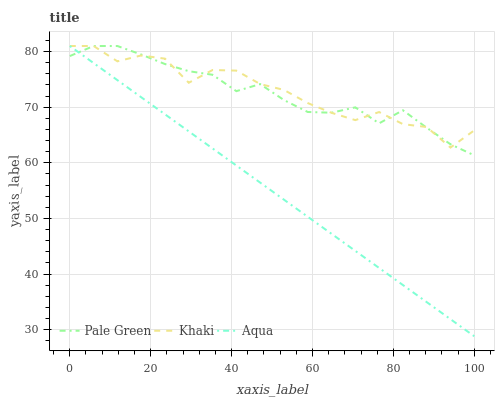Does Aqua have the minimum area under the curve?
Answer yes or no. Yes. Does Khaki have the maximum area under the curve?
Answer yes or no. Yes. Does Khaki have the minimum area under the curve?
Answer yes or no. No. Does Aqua have the maximum area under the curve?
Answer yes or no. No. Is Aqua the smoothest?
Answer yes or no. Yes. Is Khaki the roughest?
Answer yes or no. Yes. Is Khaki the smoothest?
Answer yes or no. No. Is Aqua the roughest?
Answer yes or no. No. Does Aqua have the lowest value?
Answer yes or no. Yes. Does Khaki have the lowest value?
Answer yes or no. No. Does Khaki have the highest value?
Answer yes or no. Yes. Does Pale Green intersect Aqua?
Answer yes or no. Yes. Is Pale Green less than Aqua?
Answer yes or no. No. Is Pale Green greater than Aqua?
Answer yes or no. No. 